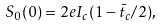<formula> <loc_0><loc_0><loc_500><loc_500>S _ { 0 } ( 0 ) = 2 e I _ { c } ( 1 - \bar { t } _ { c } / 2 ) ,</formula> 